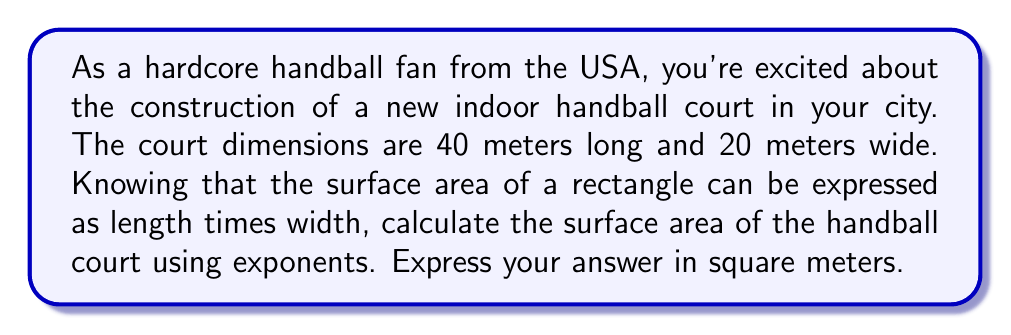Could you help me with this problem? Let's approach this step-by-step:

1) The formula for the area of a rectangle is:
   $A = l \times w$
   where $A$ is the area, $l$ is the length, and $w$ is the width.

2) We're given:
   Length $(l) = 40$ meters
   Width $(w) = 20$ meters

3) To use exponents, we can express the multiplication as:
   $A = 40 \times 20 = 40 \times 2 \times 10$

4) We can rewrite this using exponents:
   $A = 40 \times 2 \times 10^1$

5) Simplify:
   $A = 80 \times 10^1$

6) This can be written as:
   $A = 8 \times 10 \times 10^1 = 8 \times 10^2$

Therefore, the surface area of the handball court is $8 \times 10^2$ square meters.
Answer: $800$ square meters or $8 \times 10^2$ $\text{m}^2$ 